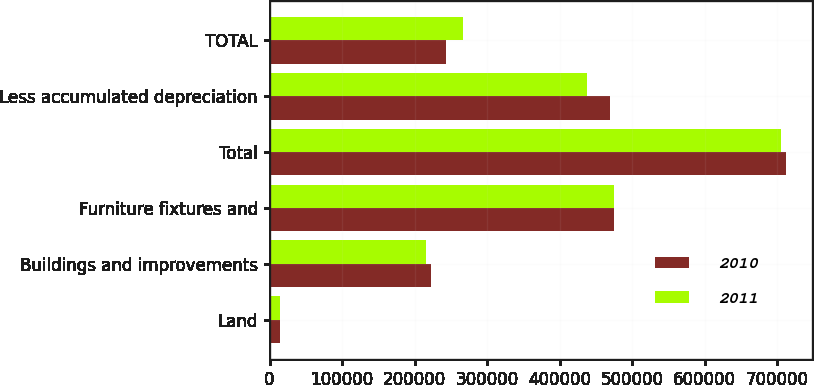<chart> <loc_0><loc_0><loc_500><loc_500><stacked_bar_chart><ecel><fcel>Land<fcel>Buildings and improvements<fcel>Furniture fixtures and<fcel>Total<fcel>Less accumulated depreciation<fcel>TOTAL<nl><fcel>2010<fcel>14359<fcel>222327<fcel>475462<fcel>712148<fcel>469240<fcel>242908<nl><fcel>2011<fcel>14359<fcel>215452<fcel>474881<fcel>704692<fcel>437523<fcel>267169<nl></chart> 